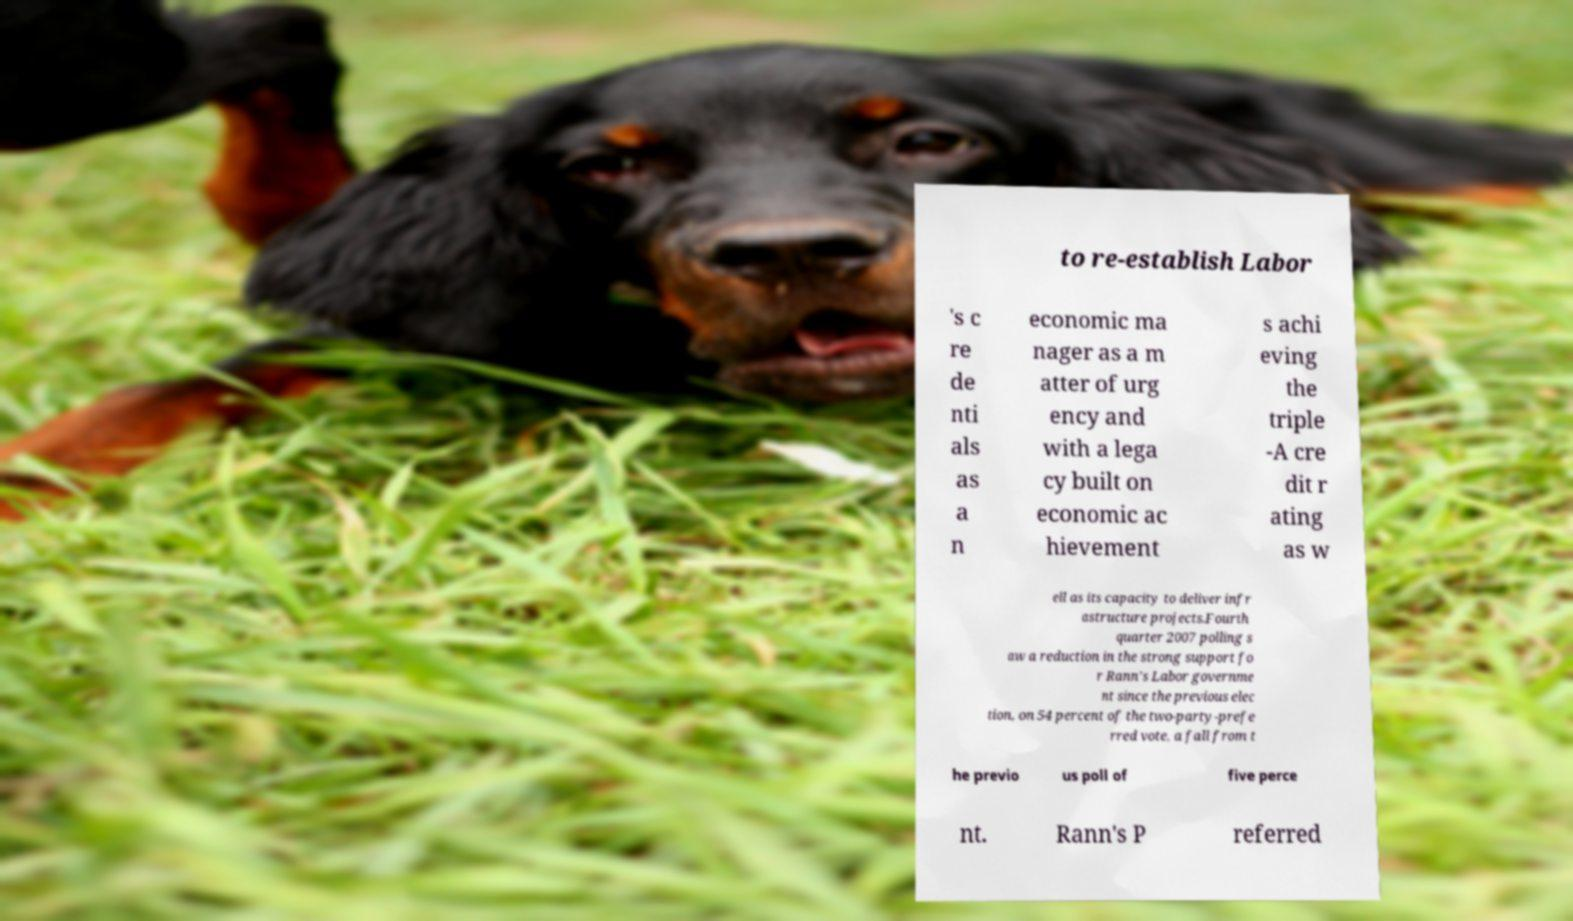Please identify and transcribe the text found in this image. to re-establish Labor 's c re de nti als as a n economic ma nager as a m atter of urg ency and with a lega cy built on economic ac hievement s achi eving the triple -A cre dit r ating as w ell as its capacity to deliver infr astructure projects.Fourth quarter 2007 polling s aw a reduction in the strong support fo r Rann's Labor governme nt since the previous elec tion, on 54 percent of the two-party-prefe rred vote, a fall from t he previo us poll of five perce nt. Rann's P referred 